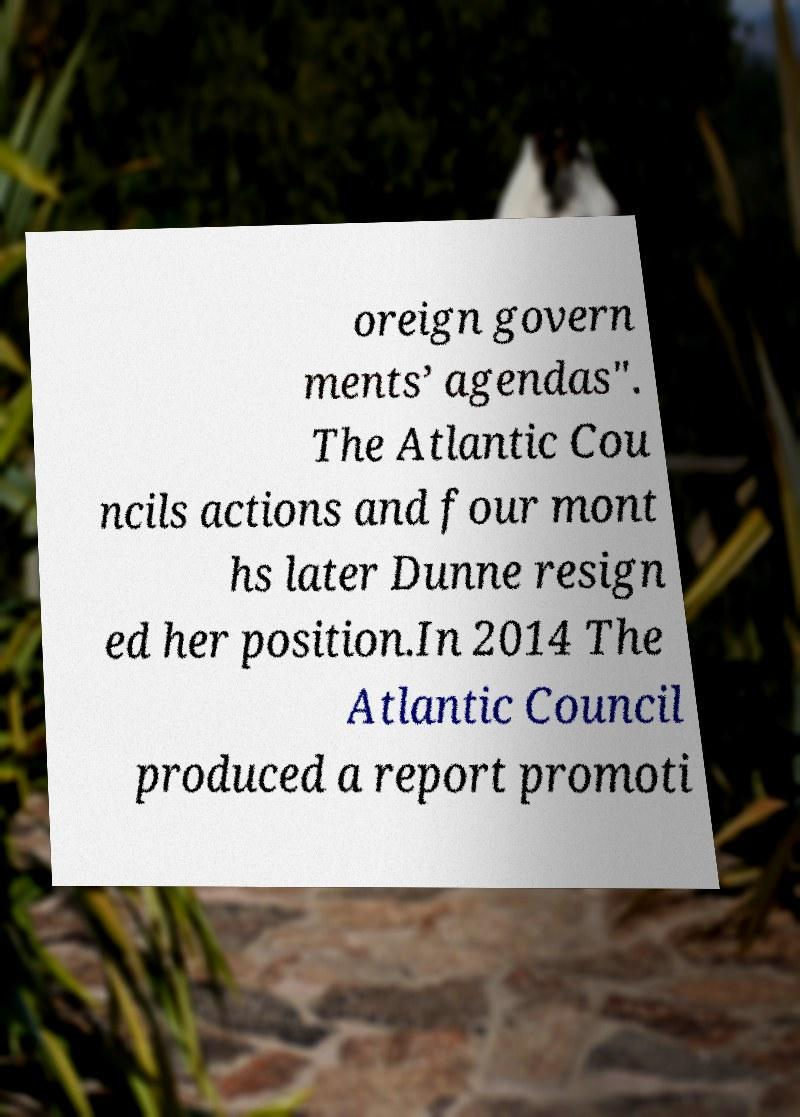Could you assist in decoding the text presented in this image and type it out clearly? oreign govern ments’ agendas". The Atlantic Cou ncils actions and four mont hs later Dunne resign ed her position.In 2014 The Atlantic Council produced a report promoti 